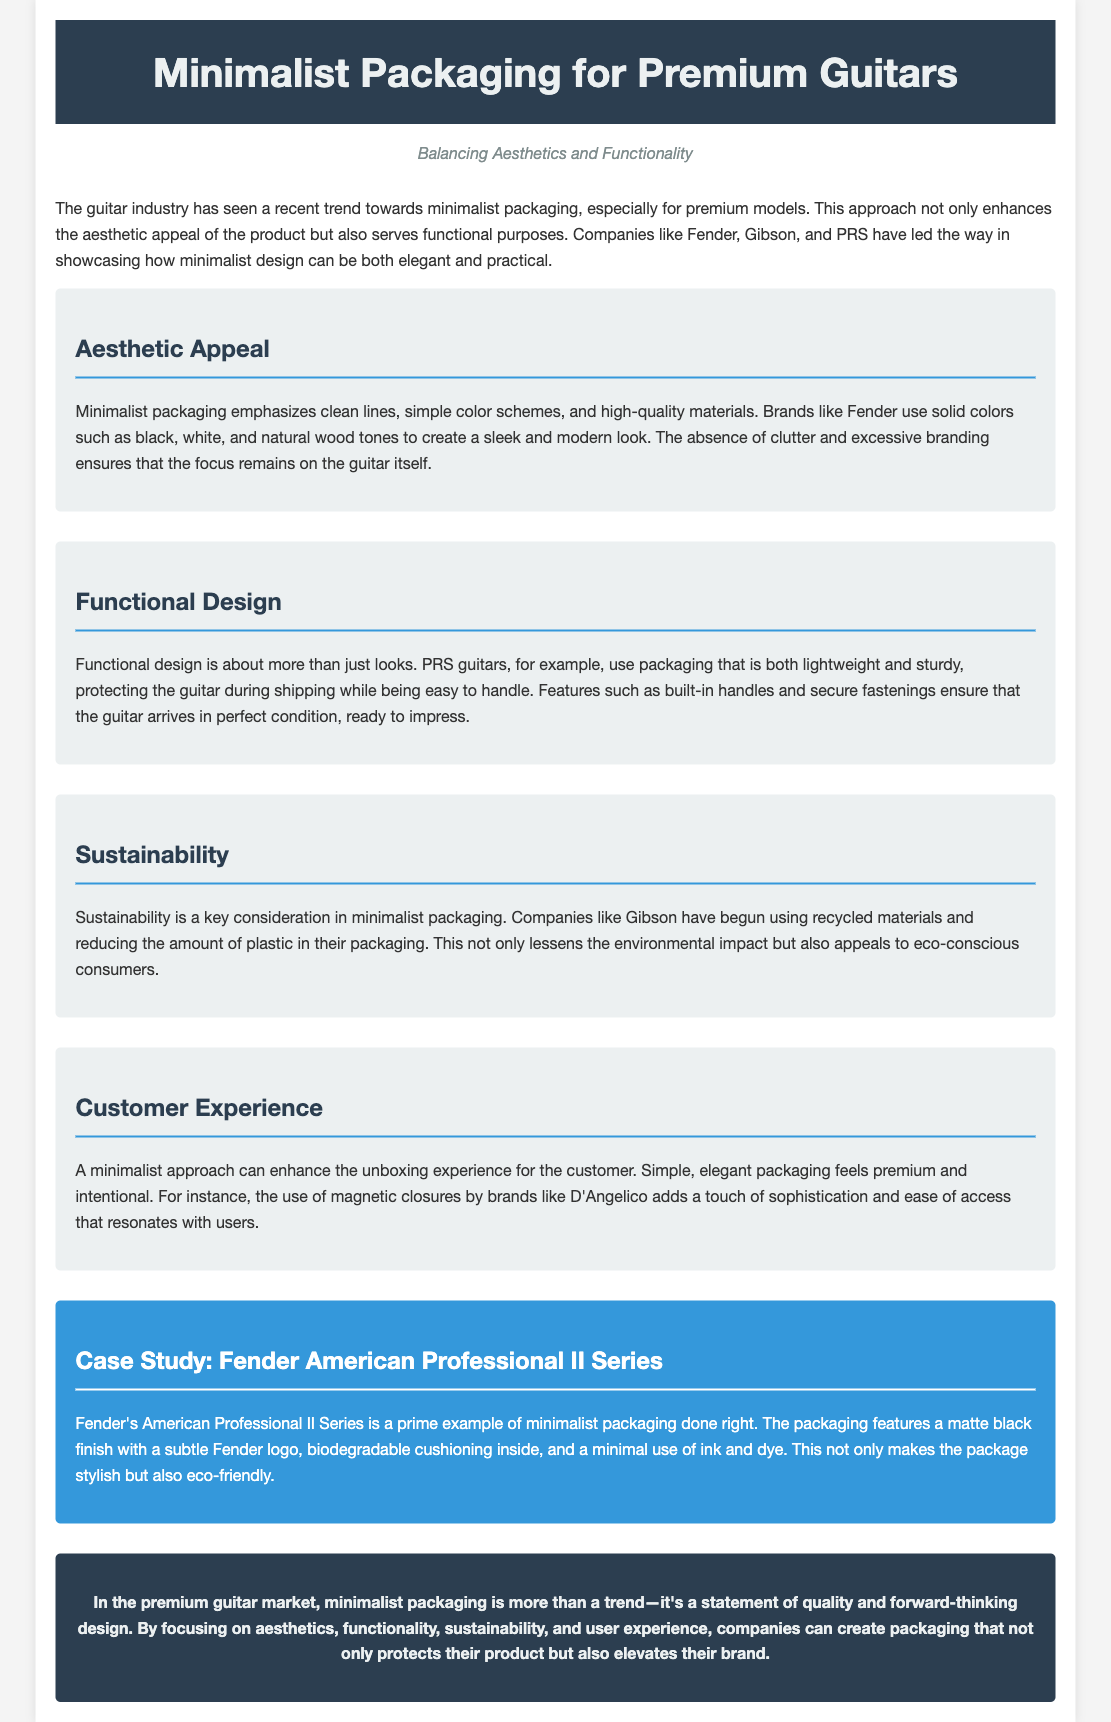What is the primary focus of minimalist packaging for premium guitars? The document states that minimalist packaging focuses on balancing aesthetics and functionality, enhancing the product while serving practical purposes.
Answer: Aesthetics and functionality Which brands are highlighted as leaders in minimalist packaging? The document mentions companies like Fender, Gibson, and PRS as leading the way in showcasing minimalist design.
Answer: Fender, Gibson, PRS What color schemes does Fender emphasize in their minimalist packaging? The document notes that Fender uses solid colors such as black, white, and natural wood tones for a sleek look.
Answer: Black, white, natural wood tones What sustainable practice is mentioned for companies like Gibson? The document discusses how Gibson uses recycled materials and reduces the amount of plastic in their packaging.
Answer: Recycled materials What feature enhances the customer experience according to the document? The document highlights that the use of magnetic closures by brands like D'Angelico adds sophistication and ease of access during unboxing.
Answer: Magnetic closures What is the packaging style of Fender's American Professional II Series? The document describes Fender's packaging as having a matte black finish with a subtle Fender logo.
Answer: Matte black finish How does PRS ensure the guitar is protected during shipping? The document states that PRS uses lightweight and sturdy packaging to protect guitars while being easy to handle.
Answer: Lightweight and sturdy packaging What does minimalist packaging enhance according to the document? The unboxing experience is enhanced by simple, elegant packaging that feels premium and intentional.
Answer: Unboxing experience 